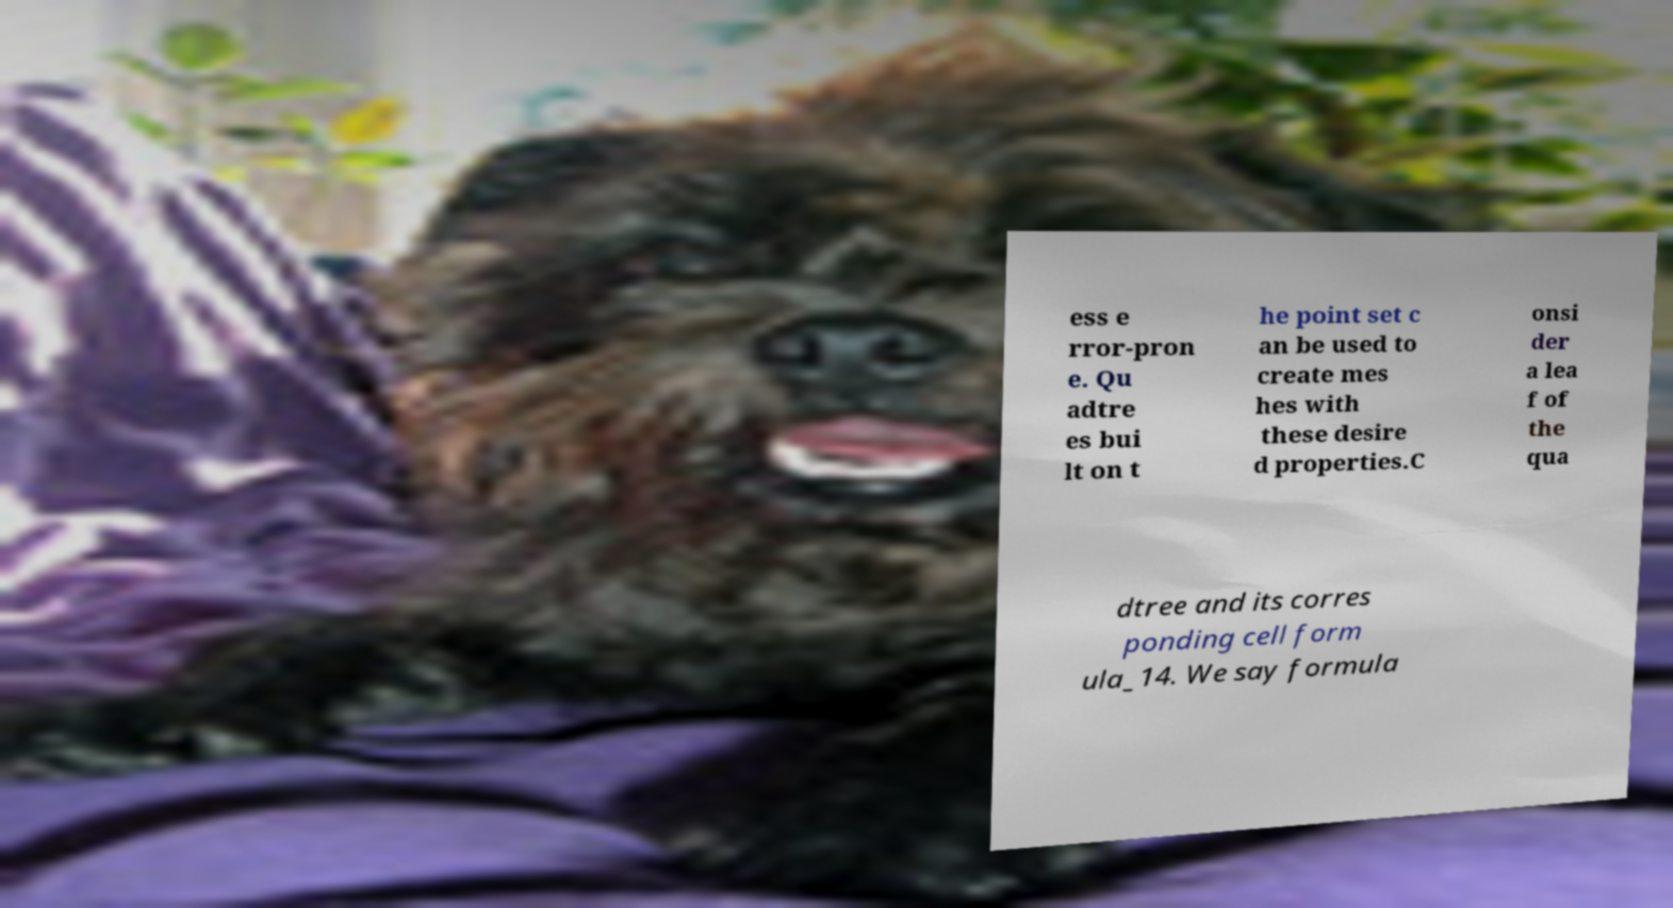Could you assist in decoding the text presented in this image and type it out clearly? ess e rror-pron e. Qu adtre es bui lt on t he point set c an be used to create mes hes with these desire d properties.C onsi der a lea f of the qua dtree and its corres ponding cell form ula_14. We say formula 